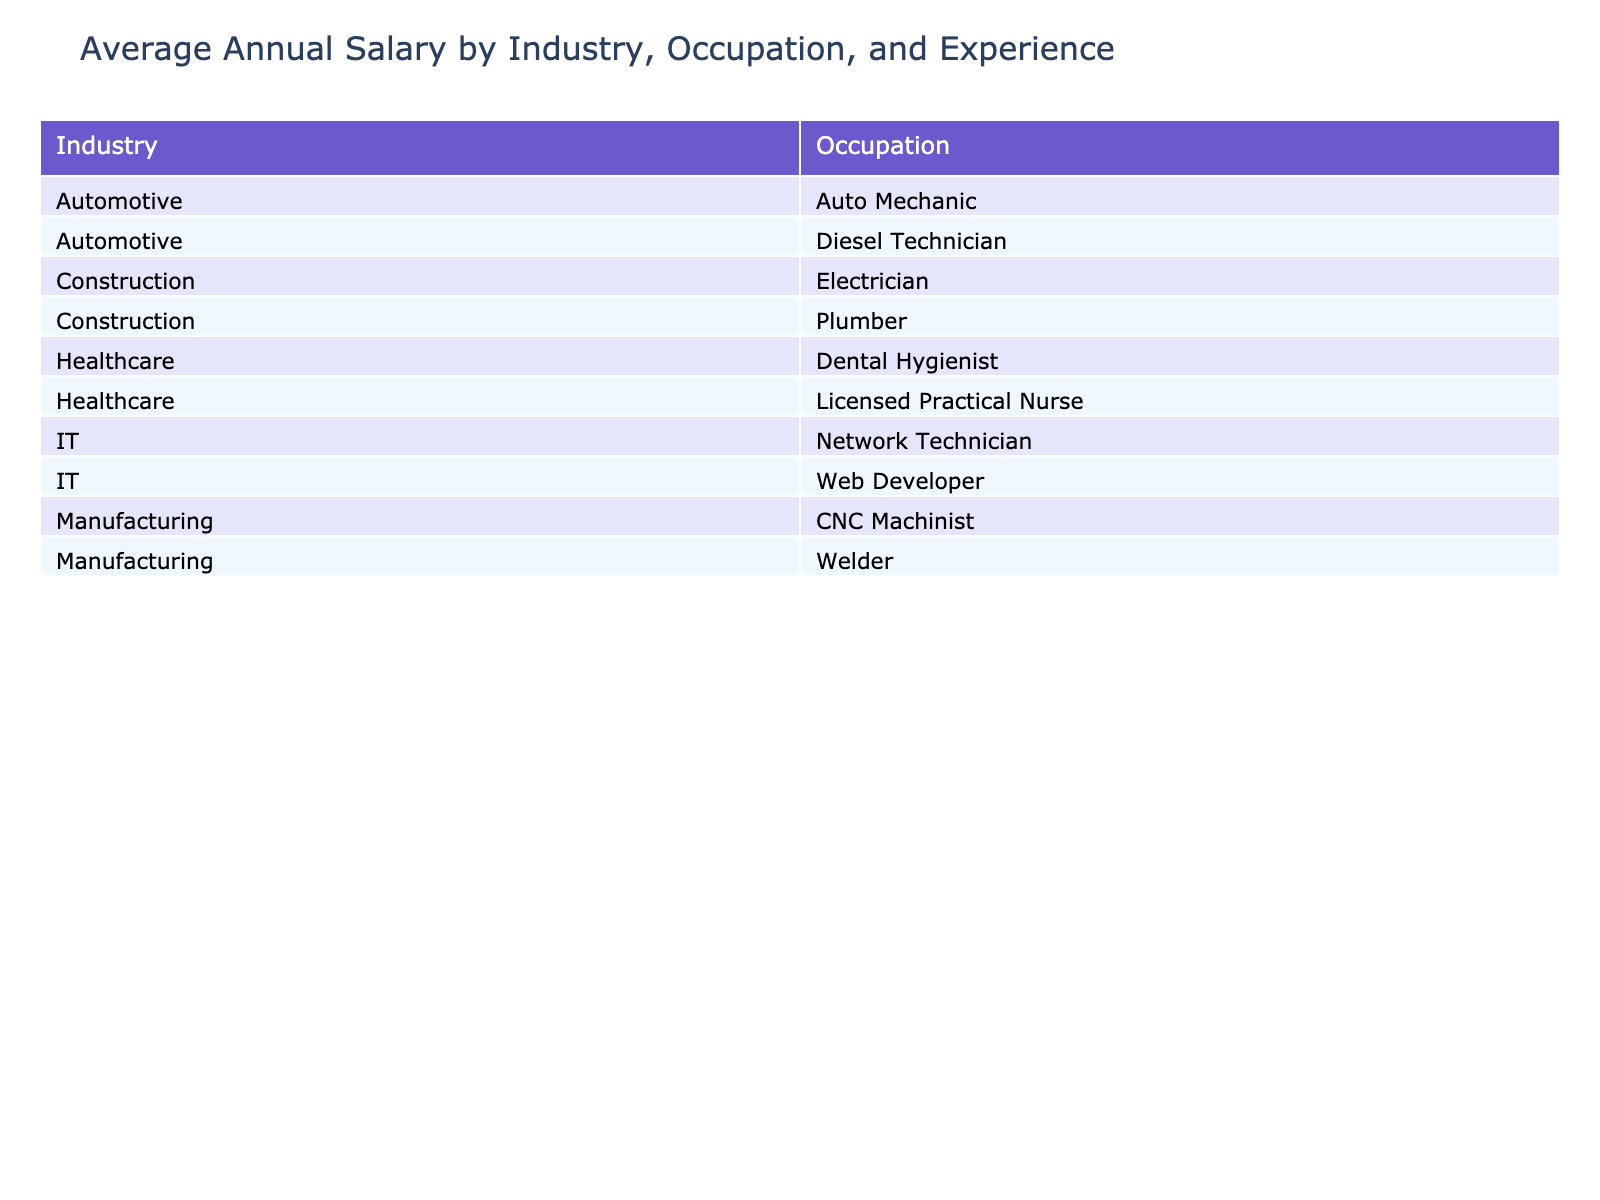What is the annual salary of a CNC Machinist with 6-10 years of experience? From the table, under the Manufacturing industry and for the occupation of CNC Machinist, the salary for those with 6-10 years of experience is listed as $65,000.
Answer: $65,000 Which industry offers the highest salary for Electricians with 3-5 years of experience? Looking at the salaries for Electricians in the table, the Construction industry has an annual salary of $60,000 for those with 3-5 years of experience, while there are no Electricians listed in other industries with such experience, making it the highest.
Answer: Construction Is the salary of a Diesel Technician with 0-2 years of experience higher than a Dental Hygienist with the same experience? The table shows that a Diesel Technician has an annual salary of $42,000 while a Dental Hygienist has an annual salary of $58,000, indicating that the Dental Hygienist's salary is higher.
Answer: No What is the difference in salary between the highest and lowest earning occupation in the Automotive industry for 6-10 years of experience? In the Automotive industry, the Auto Mechanic earns $60,000 and the Diesel Technician earns $68,000 with 6-10 years of experience. The difference is $68,000 - $60,000 = $8,000.
Answer: $8,000 What is the average salary for Plumbers with 0-2 years of experience in the West region? From the table, there is only one entry for Plumbers with 0-2 years of experience in the West region, which is $42,000. Therefore, the average salary is the same, $42,000.
Answer: $42,000 Which occupation in the Healthcare industry has the highest salary for 6-10 years of experience? Examining the Healthcare industry, the Dental Hygienist with 6-10 years of experience earns $78,000, which is more than the Licensed Practical Nurse's salary of $62,000 for the same experience. Thus, the Dental Hygienist has the highest salary.
Answer: Dental Hygienist Are there any occupations in the Manufacturing industry where the salary increases consistently with more years of experience? Analyzing the salaries for both CNC Machinists and Welders in the Manufacturing industry shows that their salaries increase from 0-2 years to 3-5 years and then to 6-10 years. Both occupations show a consistent increase in salary.
Answer: Yes What is the total salary of a Web Developer with 3-5 years of experience compared to a Network Technician with the same experience? The Web Developer earns $65,000 while the Network Technician earns $60,000 for 3-5 years of experience. Therefore, the total salary is $65,000 + $60,000 = $125,000.
Answer: $125,000 In which region do Dental Hygienists and Licensed Practical Nurses have the same experience group earning below $50,000? The table indicates that Dental Hygienists and Licensed Practical Nurses both have salaries below $50,000 for 0-2 years of experience, where the Dental Hygienist earns $58,000 and the Licensed Practical Nurse earns $44,000, thus the only region is not below $50,000 for both; the Dental Hygienist salary doesn't meet this condition.
Answer: None 